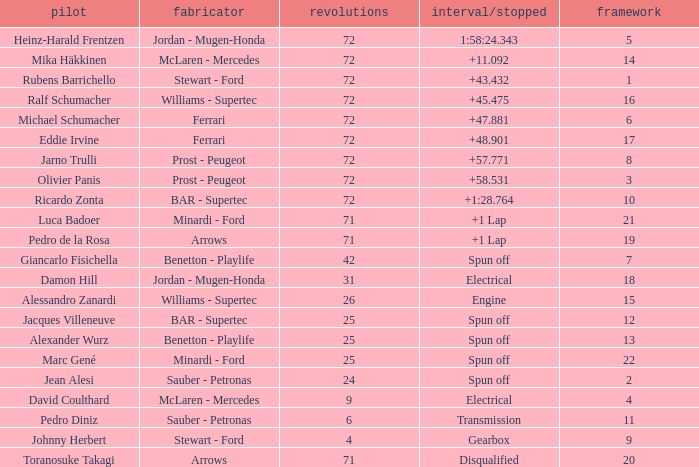When Jean Alesi had laps less than 24, what was his highest grid? None. 